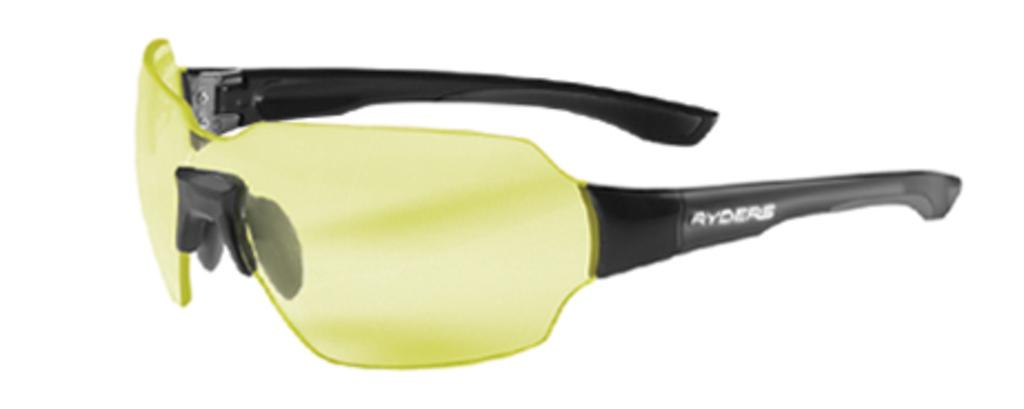What type of accessory is present in the image? There are goggles in the image. What colors are the goggles? The goggles are black and green in color. What is the color of the background in the image? The background of the image is white. What type of notebook is visible in the image? There is no notebook present in the image; it only features goggles. Can you tell me what kind of guitar is being played in the image? There is no guitar or any musical instrument present in the image. 